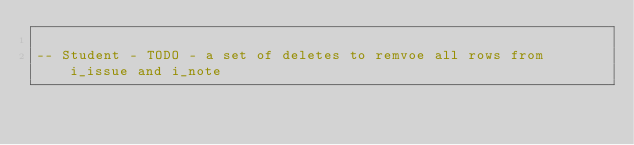Convert code to text. <code><loc_0><loc_0><loc_500><loc_500><_SQL_>
-- Student - TODO - a set of deletes to remvoe all rows from i_issue and i_note

</code> 